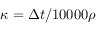Convert formula to latex. <formula><loc_0><loc_0><loc_500><loc_500>\kappa = \Delta t / 1 0 0 0 0 \rho</formula> 